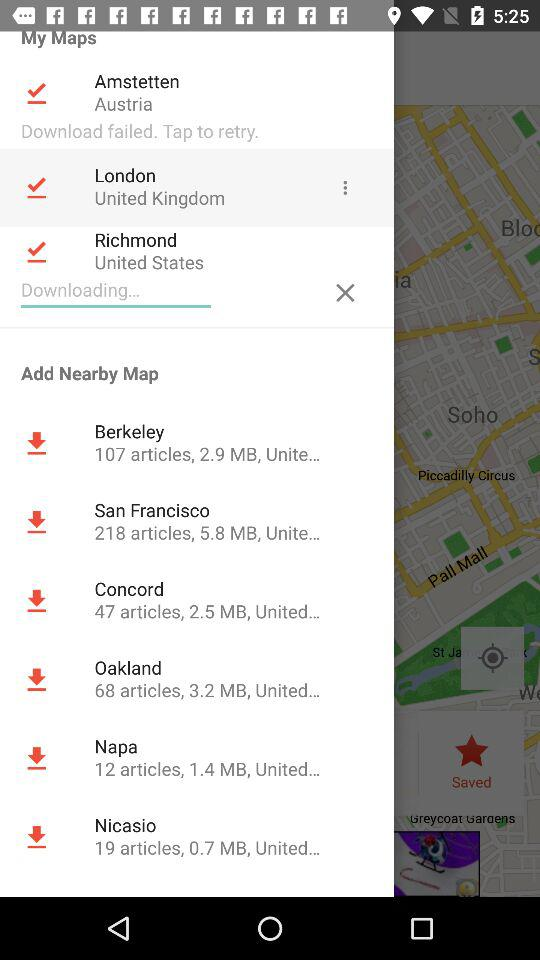What maps are added to the "My Maps" section? The maps are "Amstetten", "London" and "Richmond". 